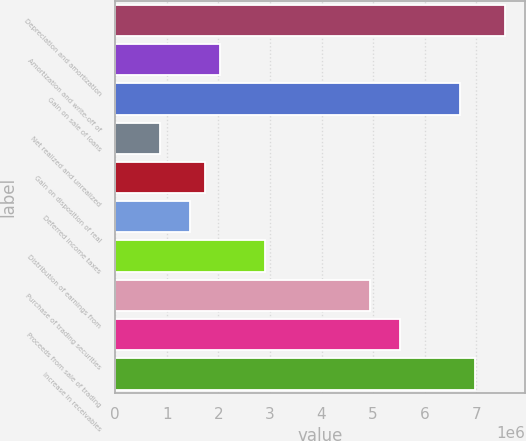<chart> <loc_0><loc_0><loc_500><loc_500><bar_chart><fcel>Depreciation and amortization<fcel>Amortization and write-off of<fcel>Gain on sale of loans<fcel>Net realized and unrealized<fcel>Gain on disposition of real<fcel>Deferred income taxes<fcel>Distribution of earnings from<fcel>Purchase of trading securities<fcel>Proceeds from sale of trading<fcel>Increase in receivables<nl><fcel>7.55981e+06<fcel>2.03697e+06<fcel>6.68778e+06<fcel>874272<fcel>1.7463e+06<fcel>1.45562e+06<fcel>2.909e+06<fcel>4.94373e+06<fcel>5.52508e+06<fcel>6.97846e+06<nl></chart> 